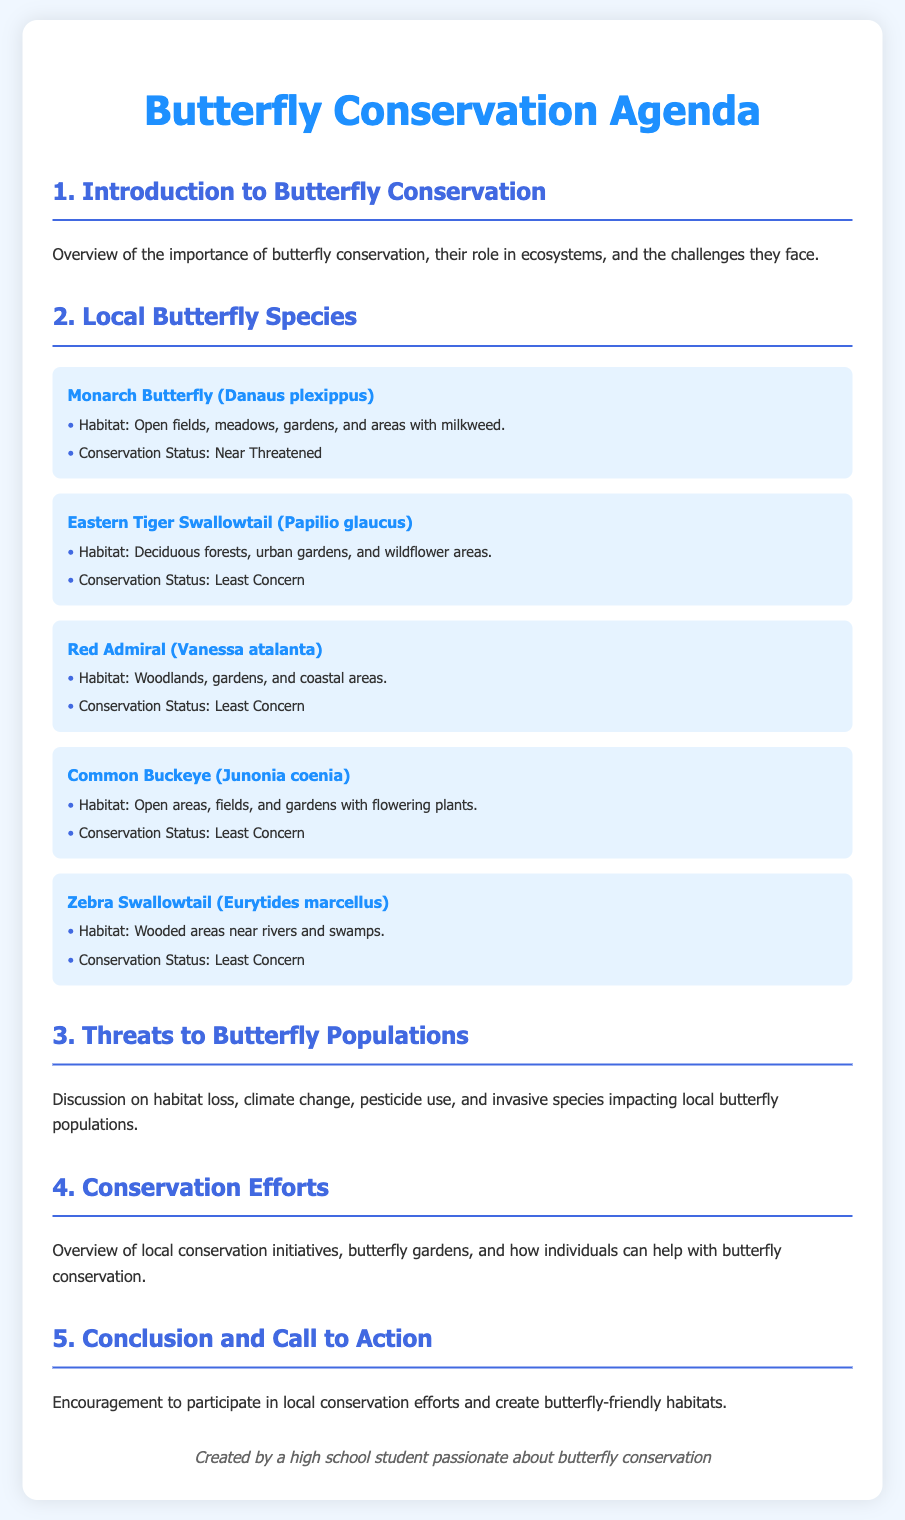What is the scientific name of the Monarch Butterfly? The scientific name is specified in the document under the species section.
Answer: Danaus plexippus Where does the Eastern Tiger Swallowtail typically reside? The habitat for the Eastern Tiger Swallowtail is listed clearly in the document.
Answer: Deciduous forests, urban gardens, and wildflower areas What is the conservation status of the Red Admiral? The conservation status is provided under each butterfly species in the document.
Answer: Least Concern Which butterfly species is classified as "Near Threatened"? The document states conservation statuses for all species and identifies the one that is Near Threatened.
Answer: Monarch Butterfly What are some threats to butterfly populations mentioned in the document? The document mentions specific threats to butterfly populations, focusing on the broader implications for conservation.
Answer: Habitat loss, climate change, pesticide use, invasive species How many local butterfly species are listed in the document? The document contains a section specifically dedicated to local butterfly species, allowing us to count them.
Answer: Five What is the overall purpose of the Butterfly Conservation Agenda? The introduction explains the importance and goals of the document regarding butterfly conservation.
Answer: Butterfly conservation awareness What type of areas does the Common Buckeye inhabit? The specific habitat for the Common Buckeye is identified in the list of species section.
Answer: Open areas, fields, and gardens with flowering plants 